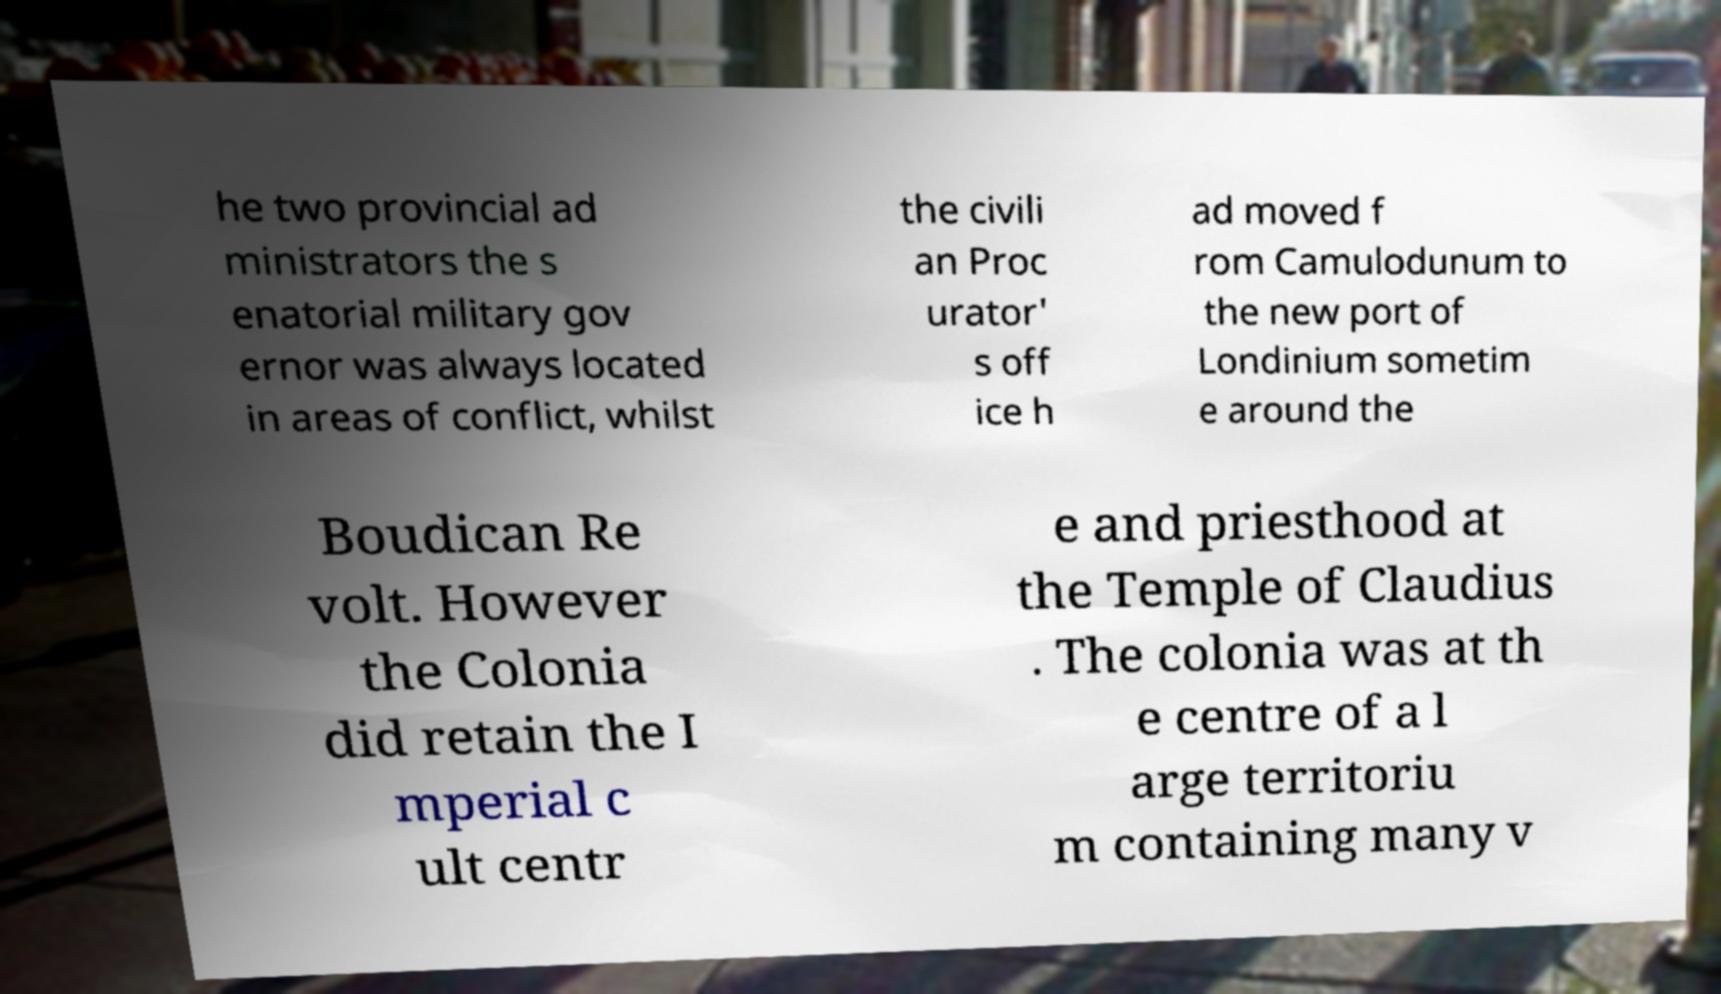Could you assist in decoding the text presented in this image and type it out clearly? he two provincial ad ministrators the s enatorial military gov ernor was always located in areas of conflict, whilst the civili an Proc urator' s off ice h ad moved f rom Camulodunum to the new port of Londinium sometim e around the Boudican Re volt. However the Colonia did retain the I mperial c ult centr e and priesthood at the Temple of Claudius . The colonia was at th e centre of a l arge territoriu m containing many v 